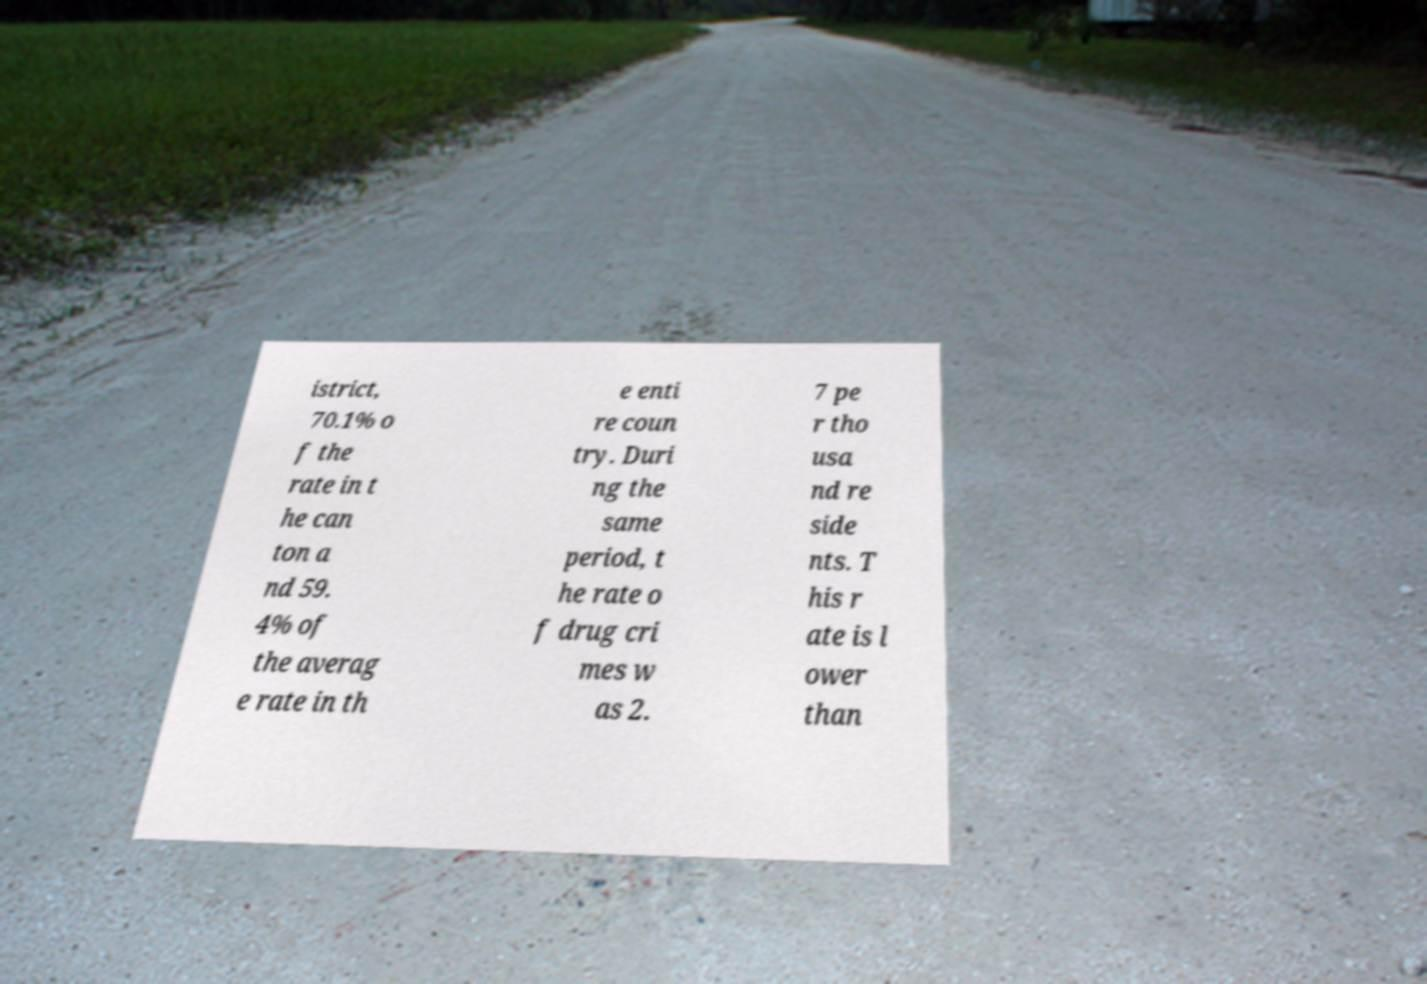Please identify and transcribe the text found in this image. istrict, 70.1% o f the rate in t he can ton a nd 59. 4% of the averag e rate in th e enti re coun try. Duri ng the same period, t he rate o f drug cri mes w as 2. 7 pe r tho usa nd re side nts. T his r ate is l ower than 